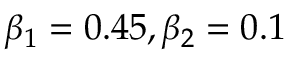<formula> <loc_0><loc_0><loc_500><loc_500>\beta _ { 1 } = 0 . 4 5 , \beta _ { 2 } = 0 . 1</formula> 